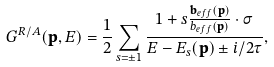<formula> <loc_0><loc_0><loc_500><loc_500>G ^ { R / A } ( \mathbf p , E ) = \frac { 1 } { 2 } \sum _ { s = \pm 1 } \frac { 1 + s \frac { \mathbf b _ { e f f } ( \mathbf p ) } { b _ { e f f } ( \mathbf p ) } \cdot \sigma } { E - E _ { s } ( \mathbf p ) \pm i / 2 \tau } ,</formula> 